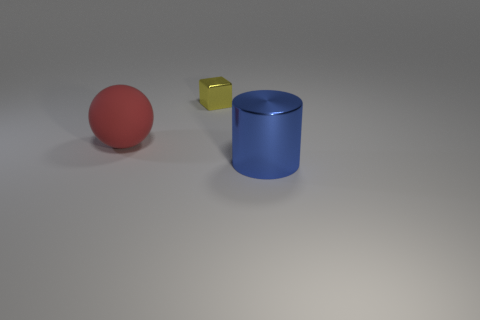Are there any other things that have the same size as the cube?
Offer a very short reply. No. Are there any other blue objects made of the same material as the small thing?
Ensure brevity in your answer.  Yes. There is a metallic thing that is to the left of the big cylinder; what color is it?
Make the answer very short. Yellow. What size is the cube that is the same material as the big cylinder?
Provide a short and direct response. Small. What number of shiny cylinders are the same size as the rubber ball?
Offer a terse response. 1. There is a object left of the yellow shiny object; is there a metal block behind it?
Your response must be concise. Yes. What number of things are either things to the right of the shiny block or small yellow shiny things?
Make the answer very short. 2. How many red balls are there?
Your answer should be compact. 1. The other thing that is the same material as the tiny object is what shape?
Make the answer very short. Cylinder. What is the size of the shiny thing that is to the left of the metallic cylinder to the right of the small yellow object?
Provide a short and direct response. Small. 